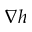Convert formula to latex. <formula><loc_0><loc_0><loc_500><loc_500>\nabla h</formula> 